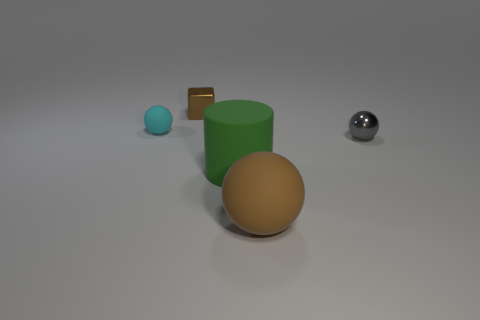Are there any other things that are the same shape as the green thing?
Offer a very short reply. No. There is a ball that is both behind the large brown ball and in front of the small matte object; what material is it made of?
Your response must be concise. Metal. There is a small object that is both on the left side of the gray shiny object and in front of the tiny brown shiny thing; what color is it?
Your answer should be very brief. Cyan. Is there any other thing of the same color as the rubber cylinder?
Keep it short and to the point. No. What is the shape of the large thing that is to the left of the brown object in front of the small sphere on the left side of the brown matte thing?
Give a very brief answer. Cylinder. What color is the other rubber object that is the same shape as the cyan object?
Make the answer very short. Brown. What color is the ball left of the large matte thing that is on the left side of the large brown sphere?
Make the answer very short. Cyan. What size is the brown object that is the same shape as the gray shiny object?
Ensure brevity in your answer.  Large. How many things are made of the same material as the cylinder?
Provide a short and direct response. 2. There is a tiny metallic object in front of the cyan rubber thing; what number of brown things are behind it?
Your answer should be compact. 1. 